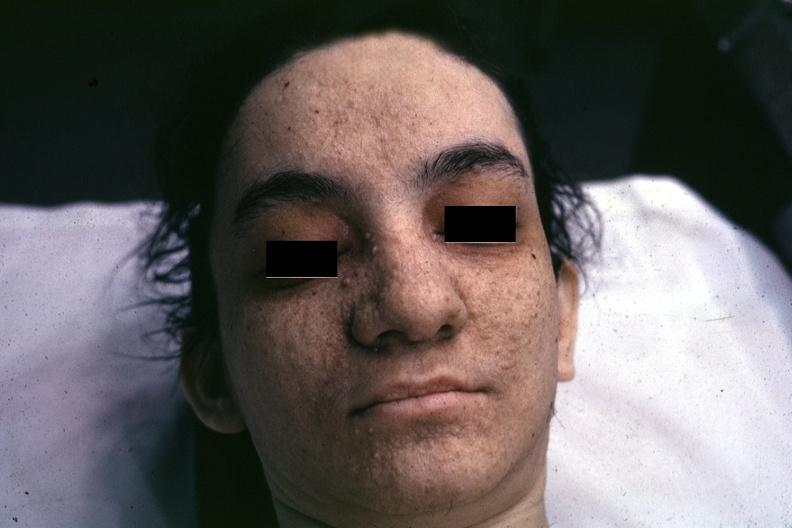what is present?
Answer the question using a single word or phrase. Face 